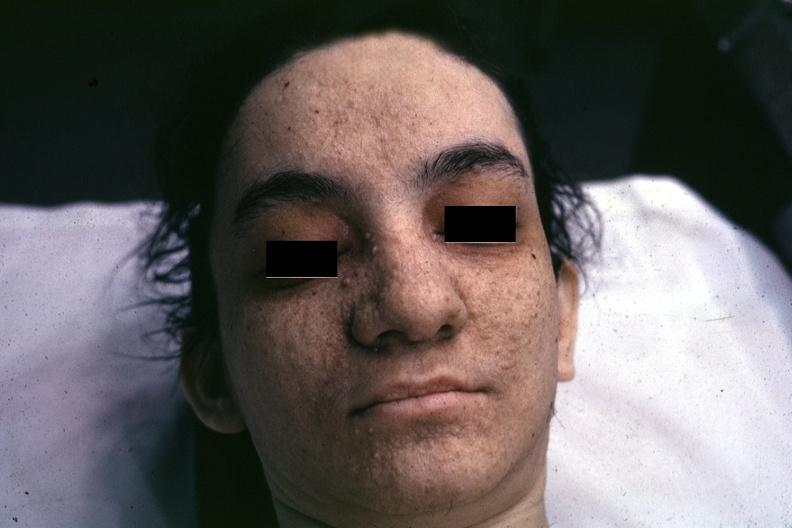what is present?
Answer the question using a single word or phrase. Face 